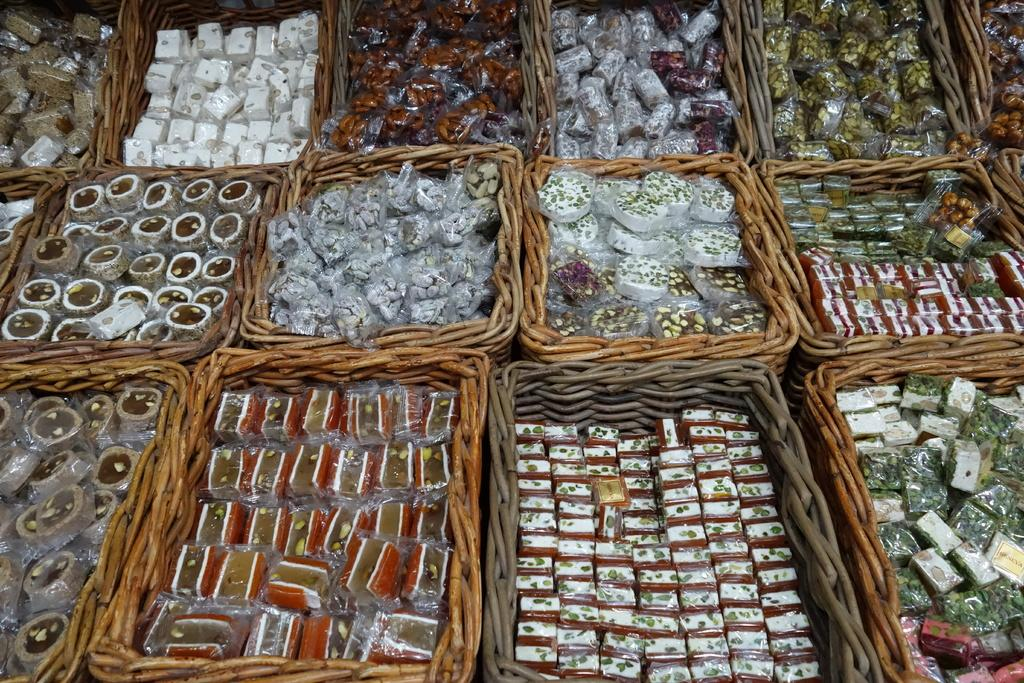What type of containers are present in the image? There are wooden boxes in the image. What is inside the wooden boxes? There are sweets in the wooden boxes. How many kittens are sitting on the chair in the image? There are no kittens or chairs present in the image. 